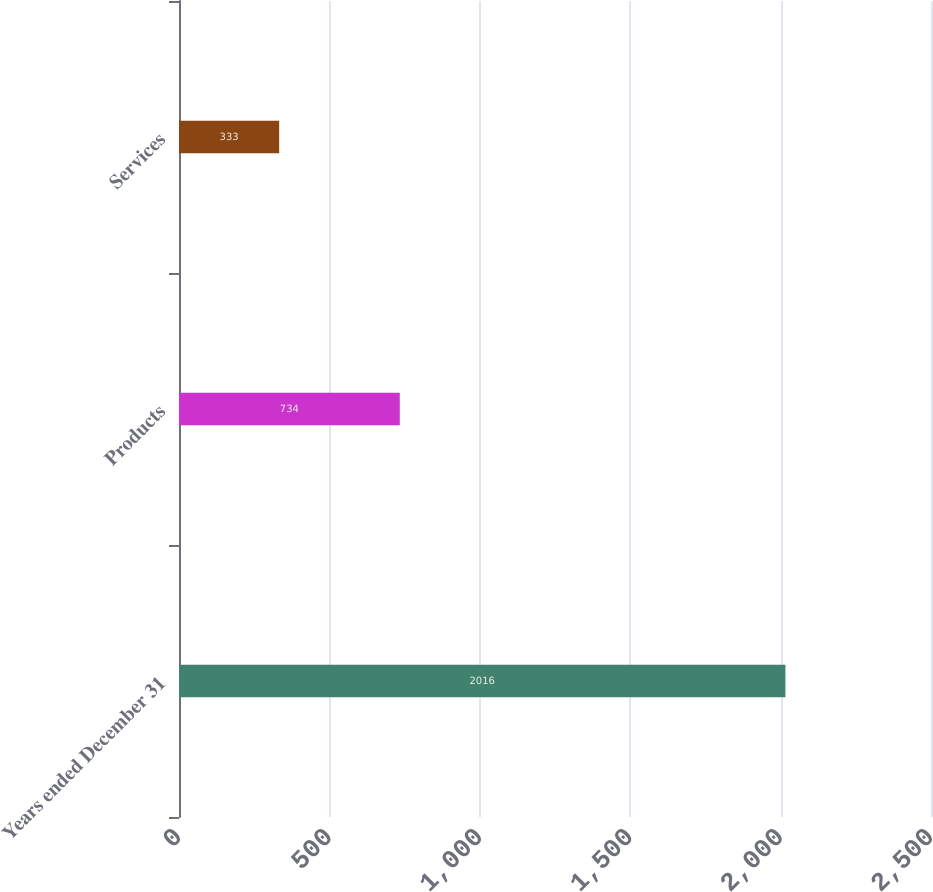Convert chart. <chart><loc_0><loc_0><loc_500><loc_500><bar_chart><fcel>Years ended December 31<fcel>Products<fcel>Services<nl><fcel>2016<fcel>734<fcel>333<nl></chart> 